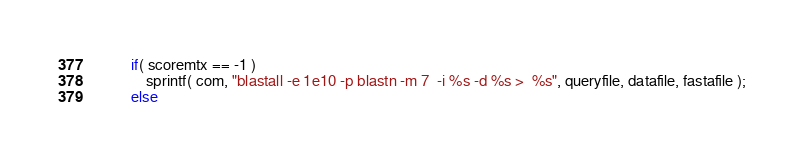<code> <loc_0><loc_0><loc_500><loc_500><_C_>

		if( scoremtx == -1 )
			sprintf( com, "blastall -e 1e10 -p blastn -m 7  -i %s -d %s >  %s", queryfile, datafile, fastafile );
		else</code> 